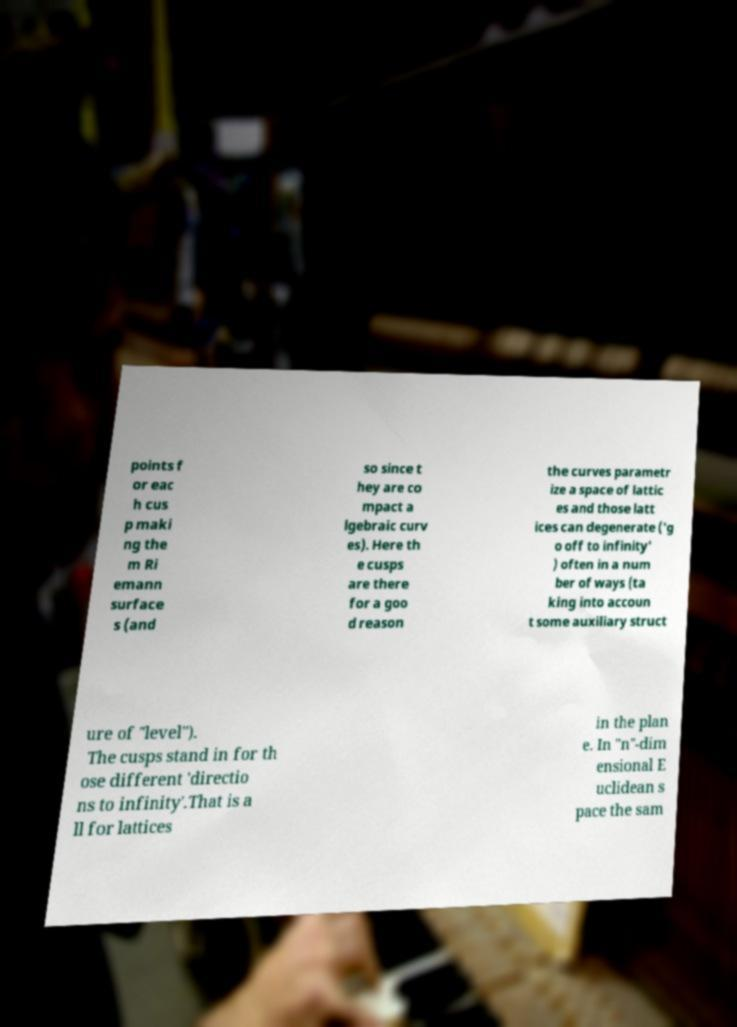Could you extract and type out the text from this image? points f or eac h cus p maki ng the m Ri emann surface s (and so since t hey are co mpact a lgebraic curv es). Here th e cusps are there for a goo d reason the curves parametr ize a space of lattic es and those latt ices can degenerate ('g o off to infinity' ) often in a num ber of ways (ta king into accoun t some auxiliary struct ure of "level"). The cusps stand in for th ose different 'directio ns to infinity'.That is a ll for lattices in the plan e. In "n"-dim ensional E uclidean s pace the sam 